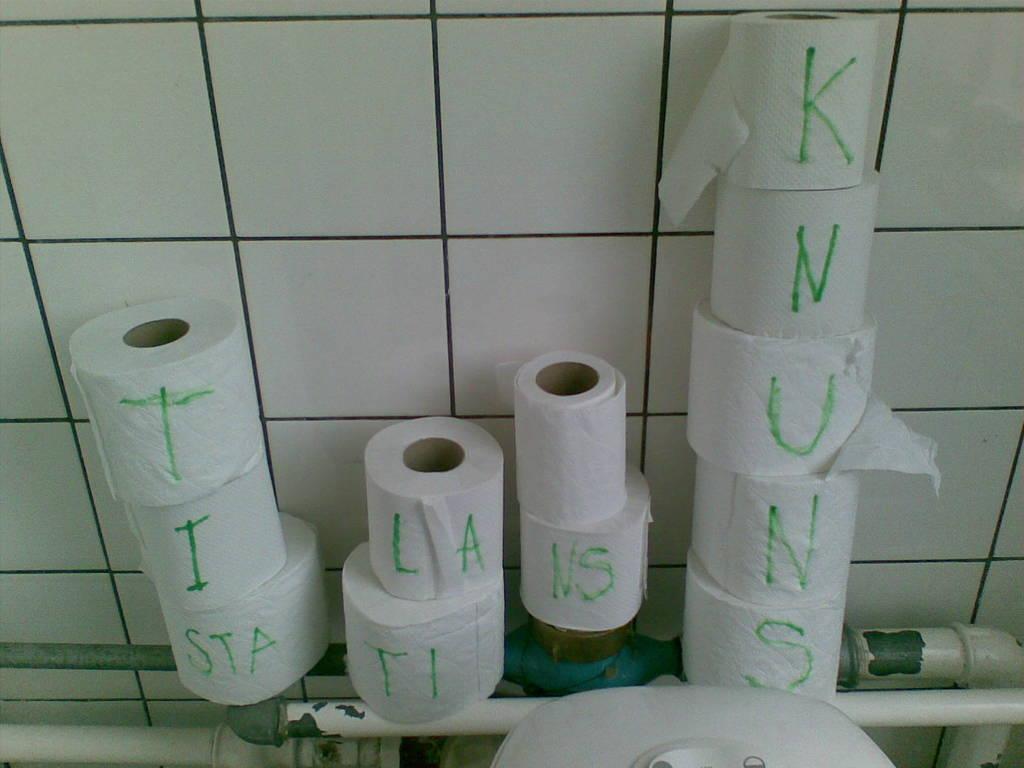In one or two sentences, can you explain what this image depicts? In this image I can see few pipes which are blue and white in color. I can see few tissue rolls on the pipes and something is written on the rolls. I can see the white colored object and the white colored wall. 